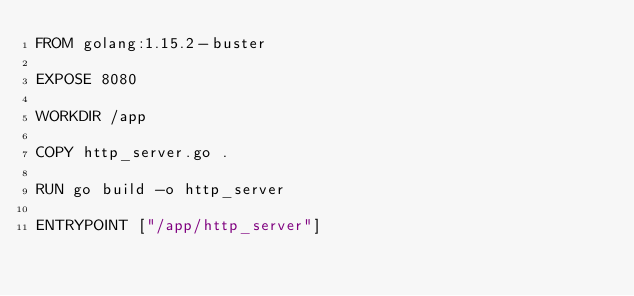<code> <loc_0><loc_0><loc_500><loc_500><_Dockerfile_>FROM golang:1.15.2-buster

EXPOSE 8080

WORKDIR /app

COPY http_server.go .

RUN go build -o http_server

ENTRYPOINT ["/app/http_server"]
</code> 